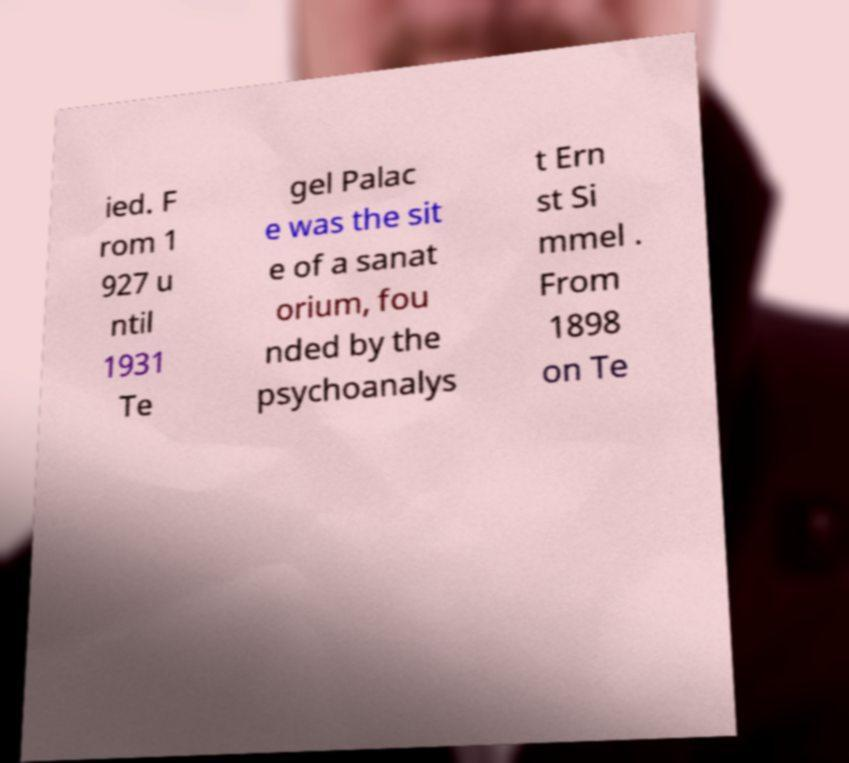I need the written content from this picture converted into text. Can you do that? ied. F rom 1 927 u ntil 1931 Te gel Palac e was the sit e of a sanat orium, fou nded by the psychoanalys t Ern st Si mmel . From 1898 on Te 